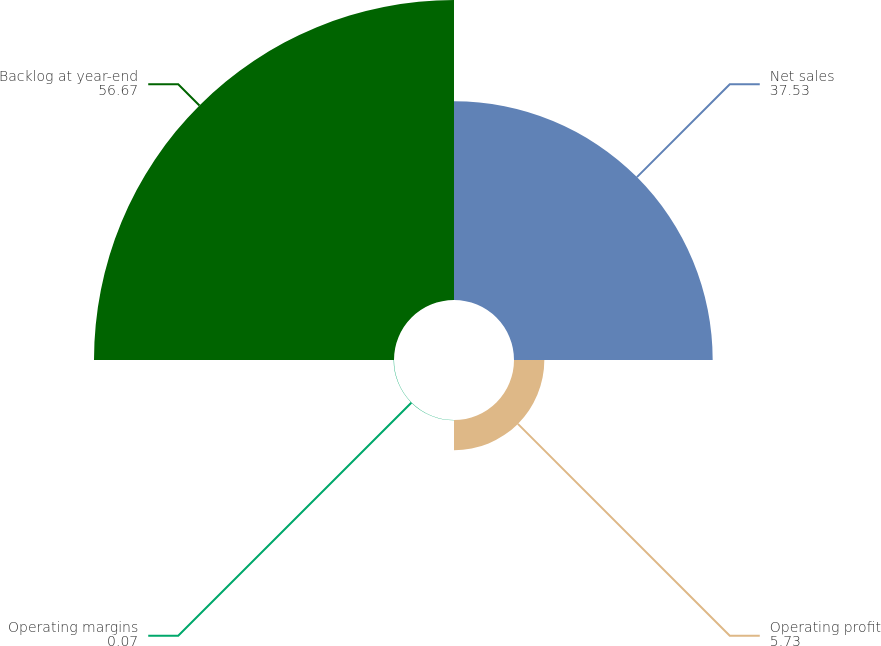Convert chart. <chart><loc_0><loc_0><loc_500><loc_500><pie_chart><fcel>Net sales<fcel>Operating profit<fcel>Operating margins<fcel>Backlog at year-end<nl><fcel>37.53%<fcel>5.73%<fcel>0.07%<fcel>56.67%<nl></chart> 